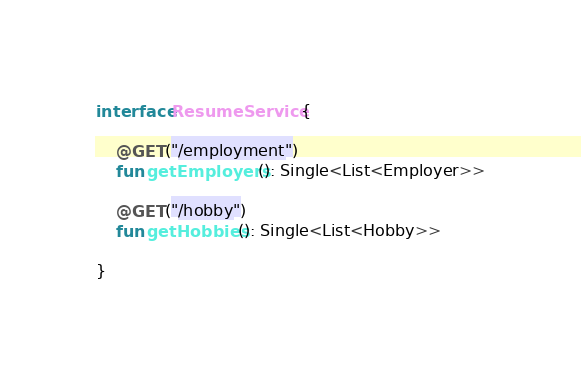Convert code to text. <code><loc_0><loc_0><loc_500><loc_500><_Kotlin_>interface ResumeService {

    @GET("/employment")
    fun getEmployers(): Single<List<Employer>>

    @GET("/hobby")
    fun getHobbies(): Single<List<Hobby>>

}
    
</code> 